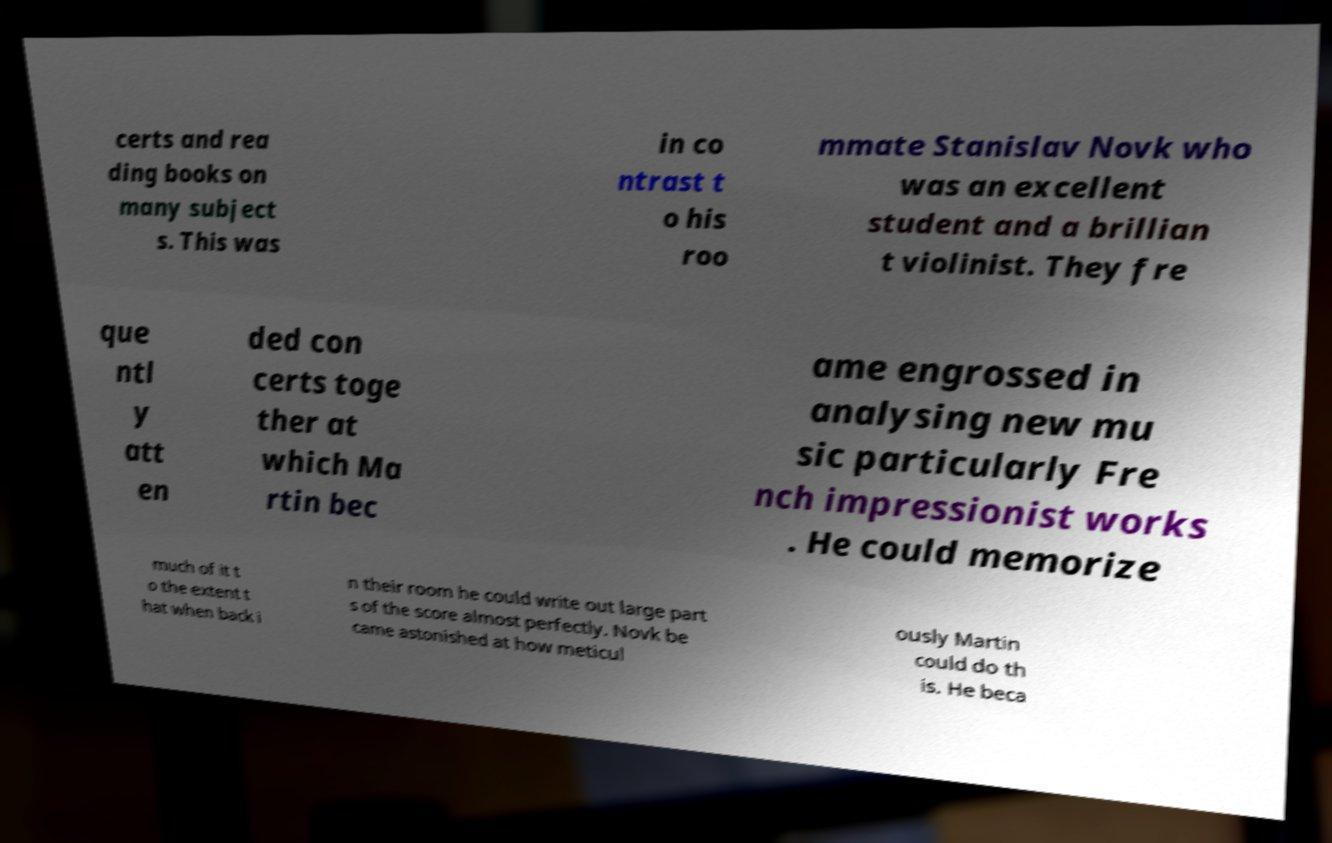Could you extract and type out the text from this image? certs and rea ding books on many subject s. This was in co ntrast t o his roo mmate Stanislav Novk who was an excellent student and a brillian t violinist. They fre que ntl y att en ded con certs toge ther at which Ma rtin bec ame engrossed in analysing new mu sic particularly Fre nch impressionist works . He could memorize much of it t o the extent t hat when back i n their room he could write out large part s of the score almost perfectly. Novk be came astonished at how meticul ously Martin could do th is. He beca 